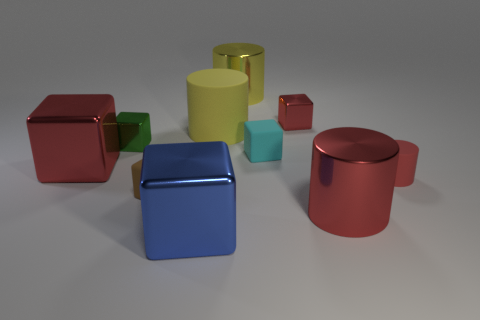Subtract all small cyan matte cubes. How many cubes are left? 5 Subtract all blue blocks. How many red cylinders are left? 2 Subtract all yellow cylinders. How many cylinders are left? 2 Subtract 1 cylinders. How many cylinders are left? 3 Subtract all big yellow cylinders. Subtract all red matte things. How many objects are left? 7 Add 4 small cyan rubber cubes. How many small cyan rubber cubes are left? 5 Add 9 red metallic cylinders. How many red metallic cylinders exist? 10 Subtract 0 cyan balls. How many objects are left? 10 Subtract all cubes. How many objects are left? 4 Subtract all gray blocks. Subtract all gray cylinders. How many blocks are left? 6 